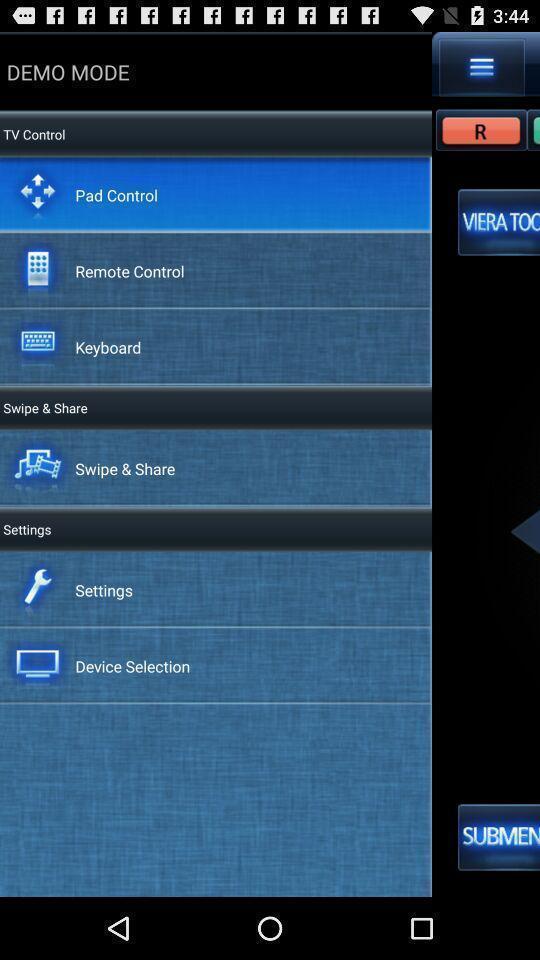Provide a detailed account of this screenshot. Screen displaying demo mode page. 